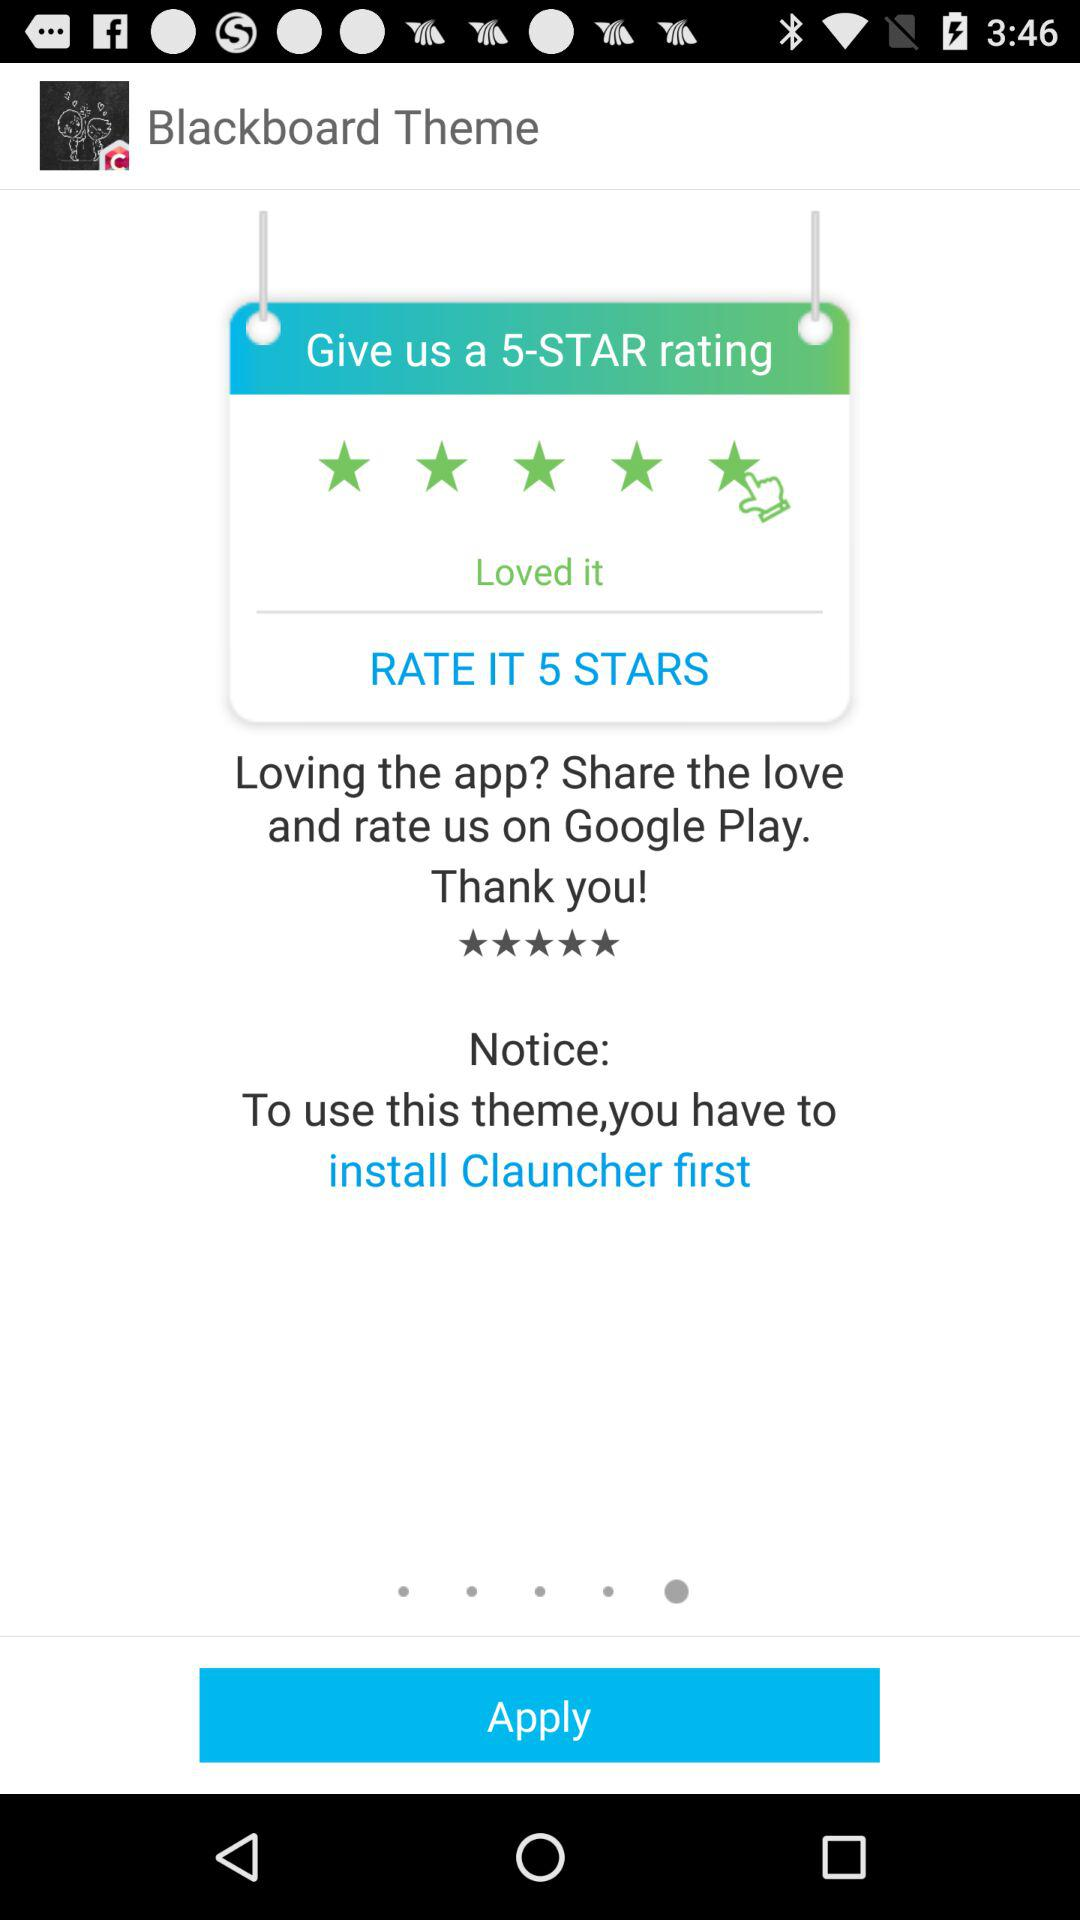What are the ratings given?
When the provided information is insufficient, respond with <no answer>. <no answer> 